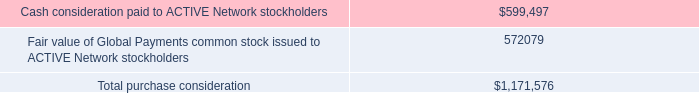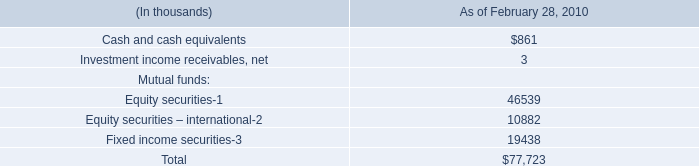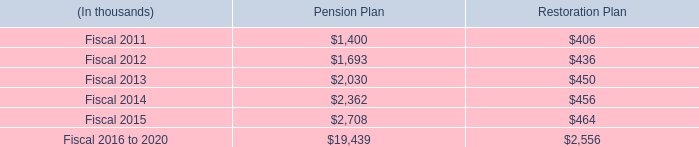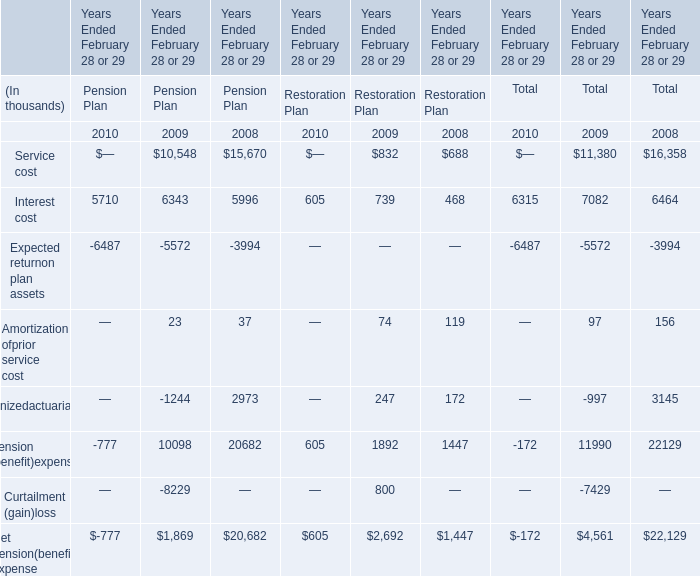What is the sum of the Restoration Planin the years where Pension Plan is greater than 2300? (in thousand) 
Computations: (456 + 464)
Answer: 920.0. 